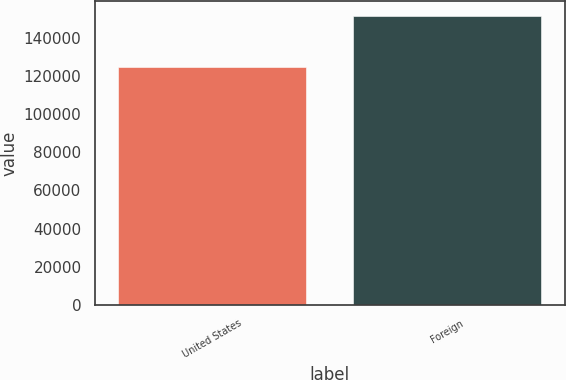Convert chart to OTSL. <chart><loc_0><loc_0><loc_500><loc_500><bar_chart><fcel>United States<fcel>Foreign<nl><fcel>124500<fcel>151457<nl></chart> 